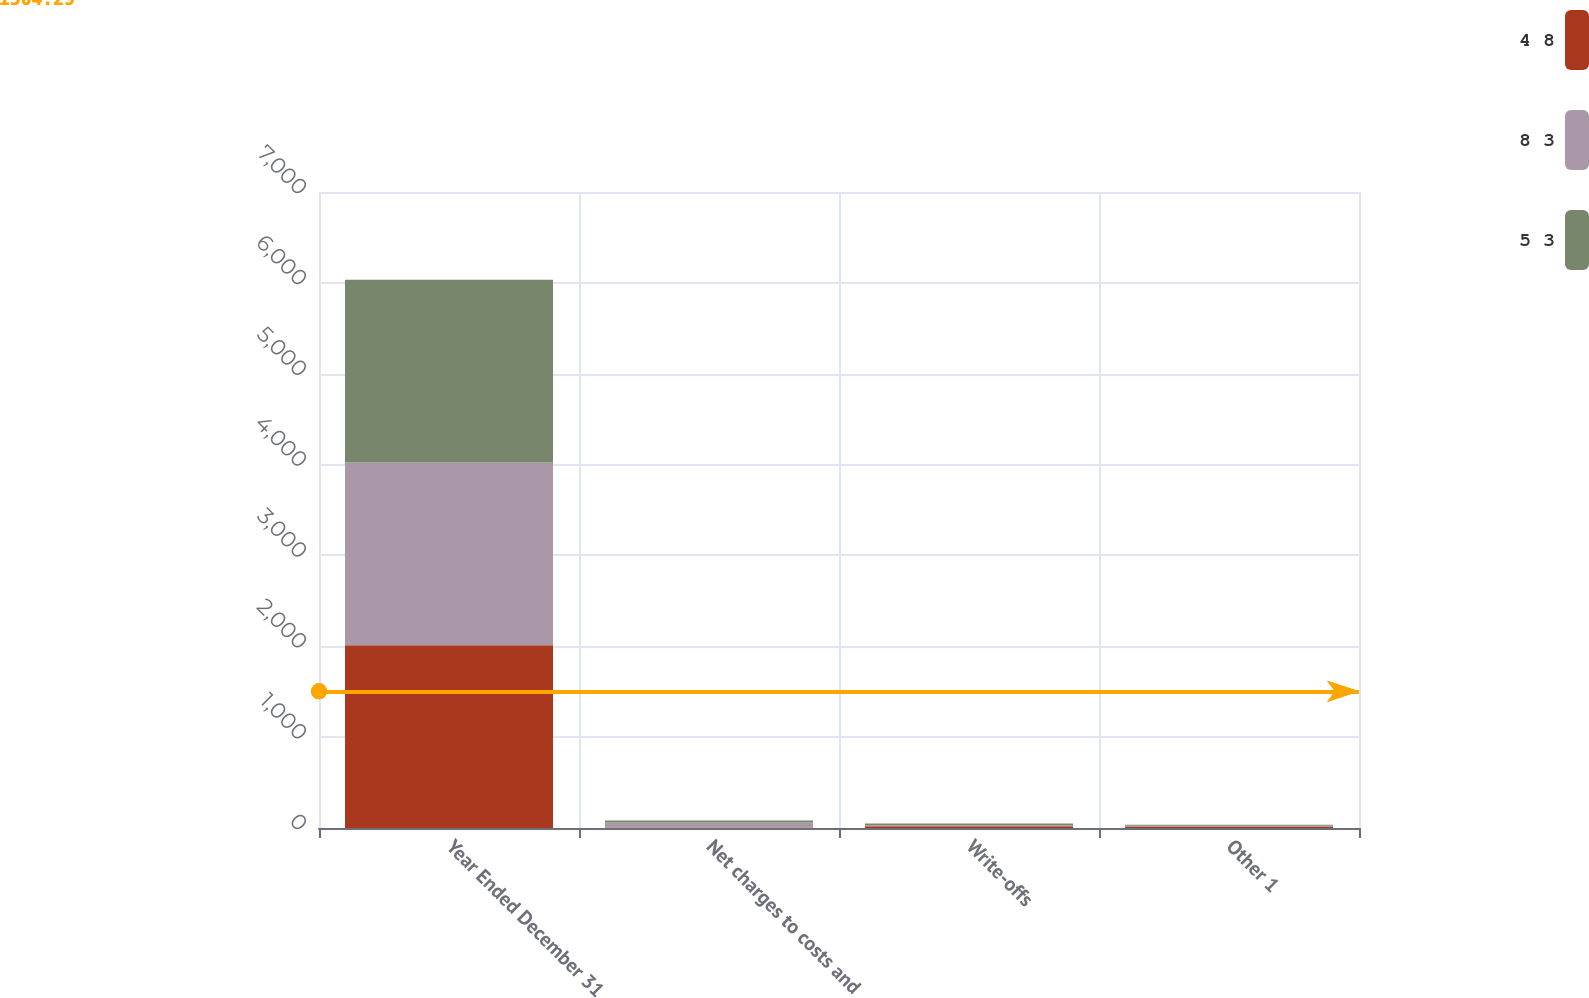Convert chart to OTSL. <chart><loc_0><loc_0><loc_500><loc_500><stacked_bar_chart><ecel><fcel>Year Ended December 31<fcel>Net charges to costs and<fcel>Write-offs<fcel>Other 1<nl><fcel>4 8<fcel>2012<fcel>5<fcel>19<fcel>16<nl><fcel>8 3<fcel>2011<fcel>56<fcel>12<fcel>9<nl><fcel>5 3<fcel>2010<fcel>21<fcel>18<fcel>10<nl></chart> 